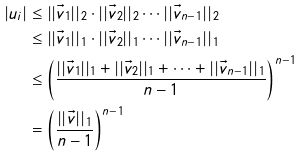Convert formula to latex. <formula><loc_0><loc_0><loc_500><loc_500>| u _ { i } | & \leq | | \vec { v } _ { 1 } | | _ { 2 } \cdot | | \vec { v } _ { 2 } | | _ { 2 } \cdots | | \vec { v } _ { n - 1 } | | _ { 2 } \\ & \leq | | \vec { v } _ { 1 } | | _ { 1 } \cdot | | \vec { v } _ { 2 } | | _ { 1 } \cdots | | \vec { v } _ { n - 1 } | | _ { 1 } \\ & \leq \left ( \frac { | | \vec { v } _ { 1 } | | _ { 1 } + | | \vec { v } _ { 2 } | | _ { 1 } + \cdots + | | \vec { v } _ { n - 1 } | | _ { 1 } } { n - 1 } \right ) ^ { n - 1 } \\ & = \left ( \frac { | | \vec { v } | | _ { 1 } } { n - 1 } \right ) ^ { n - 1 } \\</formula> 